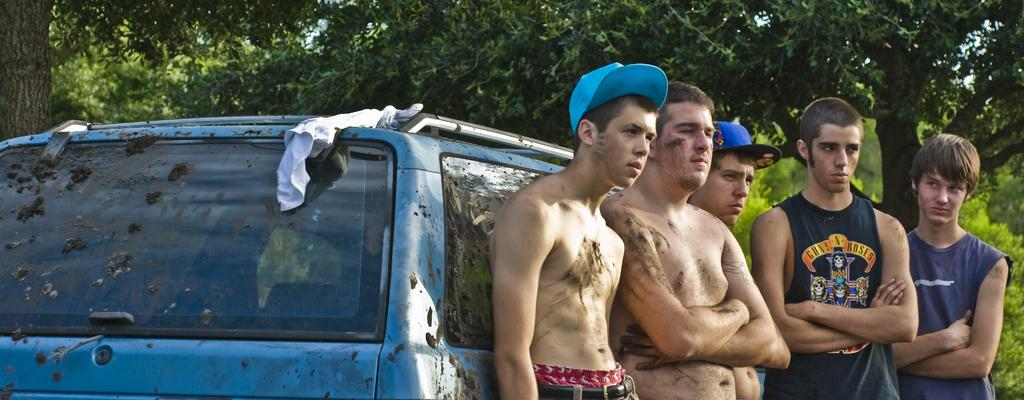What can be seen in the image involving transportation? There are people standing beside a car in the image. What type of natural scenery is visible in the background? There are trees in the background of the image. What type of insect can be seen crawling on the boat in the image? There is no boat present in the image, and therefore no insects can be seen crawling on it. 